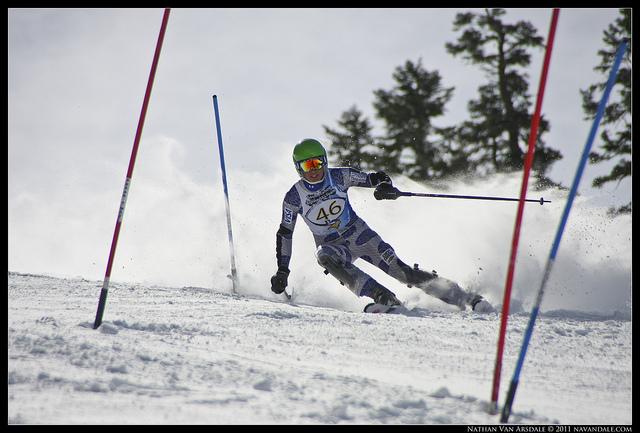Is this one person or two?
Short answer required. 1. What number is written on his shirt?
Short answer required. 46. What is the man doing?
Concise answer only. Skiing. What colors is he wearing?
Be succinct. White and blue. What color are the ski pants?
Keep it brief. Blue. What color are the poles in the snow?
Quick response, please. Red and blue. What color are the goggles?
Quick response, please. Red. 